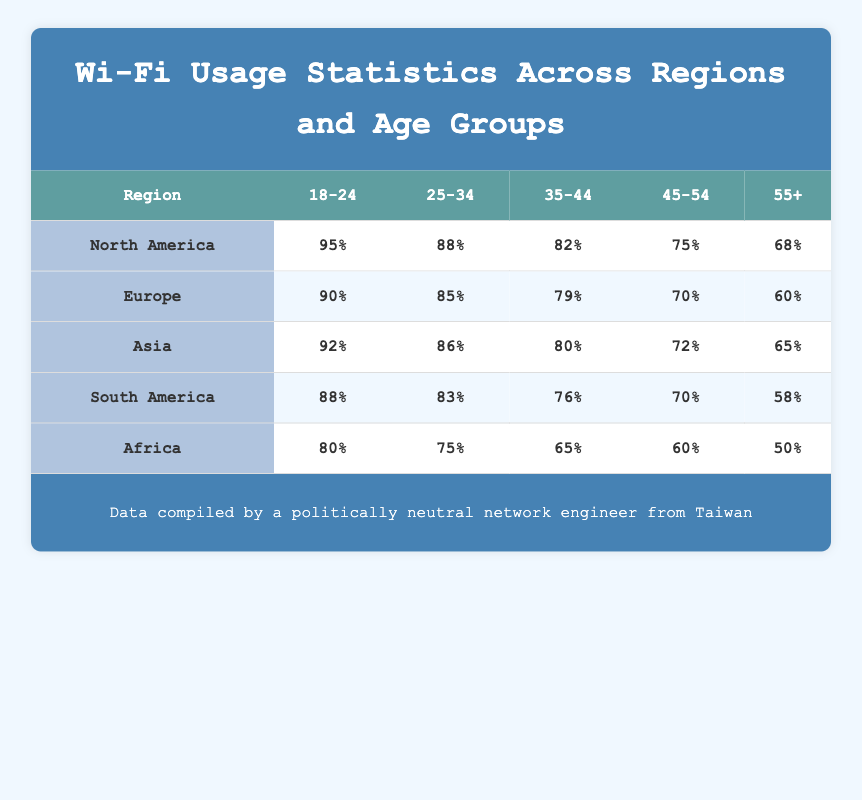What percentage of users aged 25-34 in South America use Wi-Fi? According to the table, the percentage usage for users aged 25-34 in South America is listed directly as 83%.
Answer: 83% Which region has the highest percentage of Wi-Fi usage among the 45-54 age group? From the table, North America shows a Wi-Fi usage of 75% for the 45-54 age group, while Europe shows 70%, Asia shows 72%, South America shows 70%, and Africa shows 60%. Hence, North America has the highest percentage.
Answer: North America What is the average percentage of Wi-Fi usage for users aged 55+ across all regions? To find the average, we take the percentage values from each region: North America (68%), Europe (60%), Asia (65%), South America (58%), and Africa (50%). Adding them gives 68 + 60 + 65 + 58 + 50 = 301, and dividing by the number of regions (5) results in an average of 301/5 = 60.2%.
Answer: 60.2% Is the percentage usage of Wi-Fi for users aged 18-24 in Asia higher than in Europe? The table indicates that Asia has a usage percentage of 92% for the 18-24 age group, whereas Europe has 90%. Since 92% is greater than 90%, the statement is true.
Answer: Yes Which age group in Africa has the lowest percentage of Wi-Fi usage? By comparing the percentages for each age group in Africa, we see: 80% (18-24), 75% (25-34), 65% (35-44), 60% (45-54), and 50% (55+). The lowest percentage is 50%, which corresponds to the 55+ age group.
Answer: 55+ 